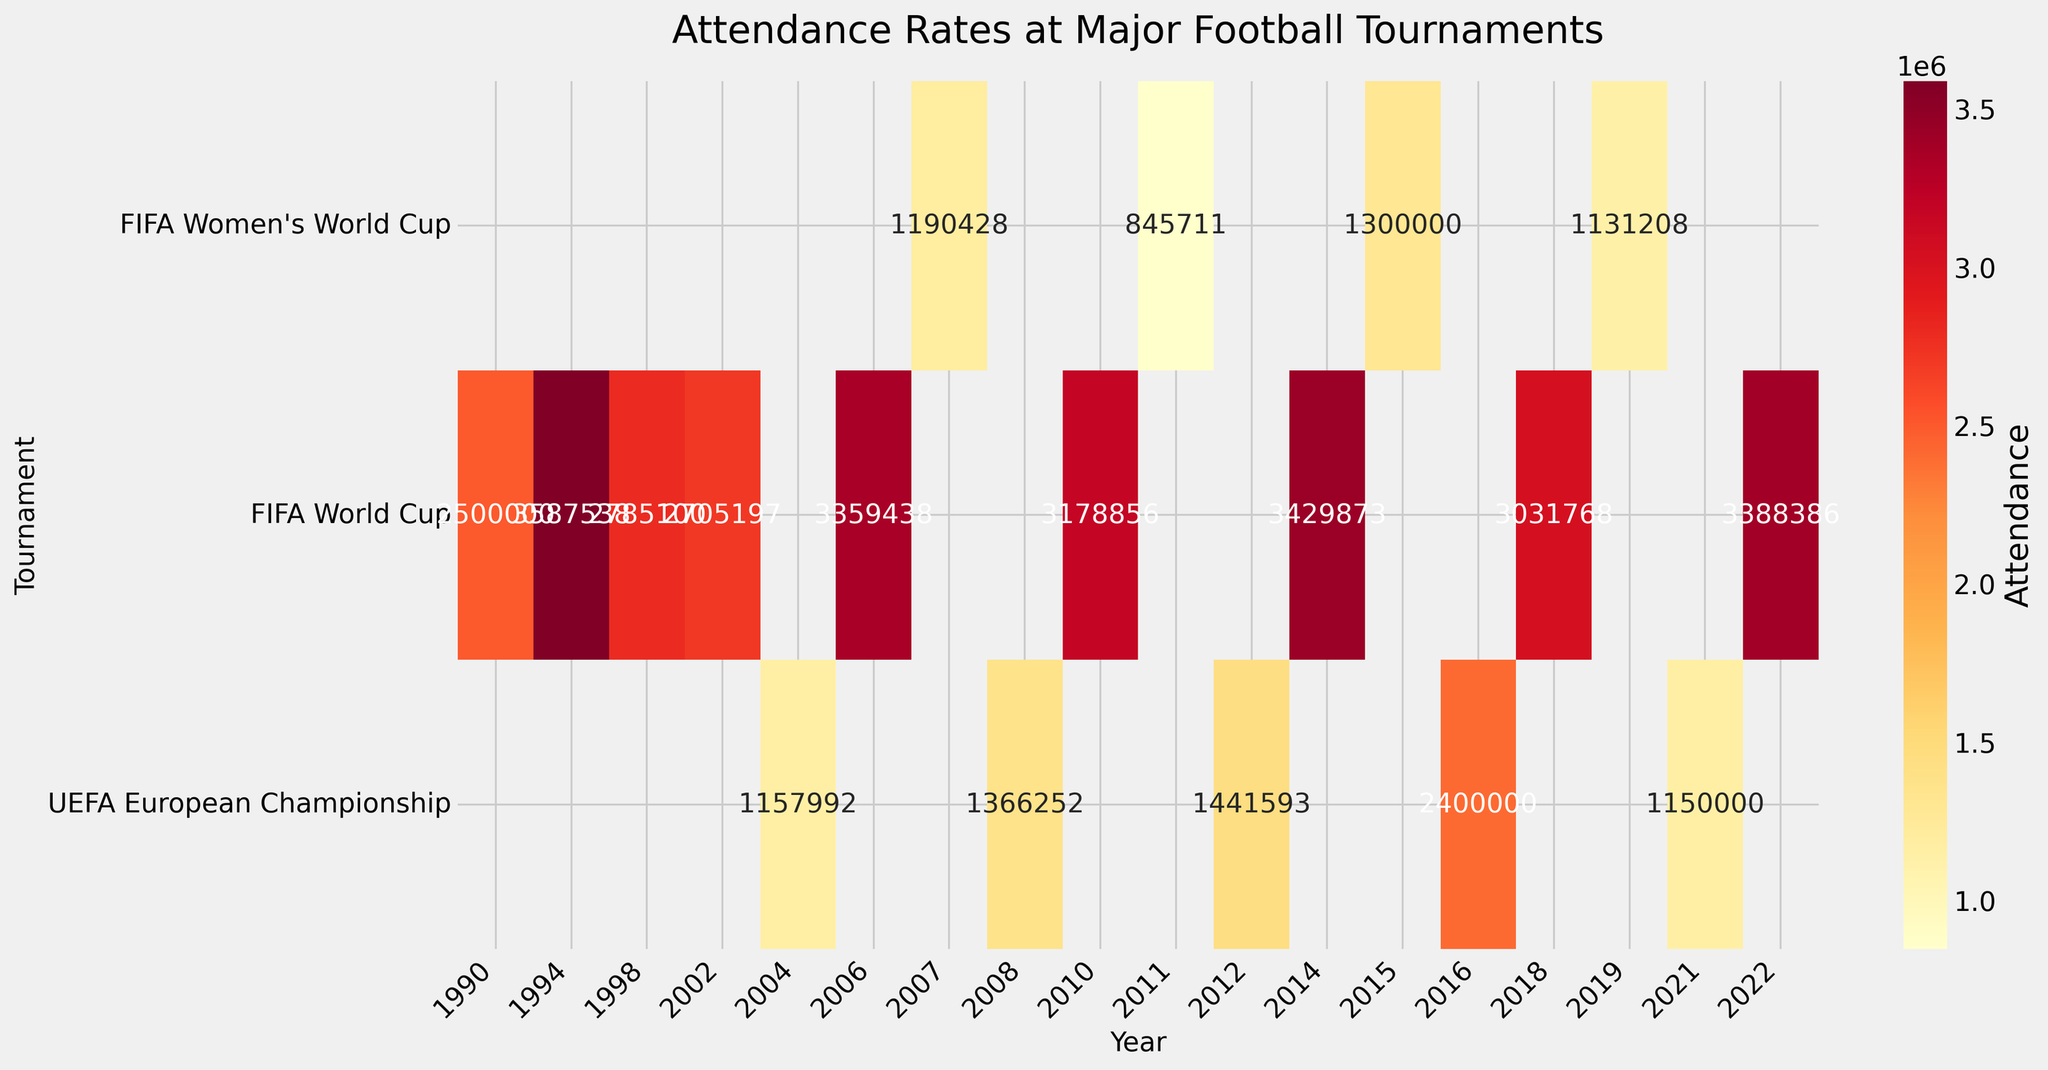What is the title of the figure? The title is usually displayed prominently at the top of the figure. In this case, the title is located above the heatmap.
Answer: Attendance Rates at Major Football Tournaments Which tournament had the highest attendance in 1994? Looking at the column for the year 1994, locate the cell with the highest value. The highest attendance in 1994 is under the FIFA World Cup.
Answer: FIFA World Cup What was the attendance at the UEFA European Championship in 2012? To find this information, look in the row for the UEFA European Championship and trace it to the column for the year 2012. The attendance value in this cell is the answer.
Answer: 1441593 Which years had the FIFA World Cup with attendance greater than 3 million? Examine the FIFA World Cup row for attendance values greater than 3 million and note the corresponding years. The years are 1994, 2006, 2010, 2014, 2018, and 2022.
Answer: 1994, 2006, 2010, 2014, 2018, 2022 What is the average attendance for the FIFA Women's World Cup from 2007 to 2019? Identify the attendance values for the FIFA Women's World Cup across 2007, 2011, 2015, and 2019, then calculate the average. The values are 1190428, 845711, 1300000, and 1131208 respectively. The average is (1190428 + 845711 + 1300000 + 1131208) / 4 = 1114336.75.
Answer: 1114336.75 How does the attendance in the 1998 FIFA World Cup compare to the 2002 FIFA World Cup? Compare the attendance values for the FIFA World Cup in 1998 and 2002. The values are 2785100 in 1998 and 2705197 in 2002. The 1998 FIFA World Cup had a higher attendance.
Answer: 1998 had higher attendance Which tournament has the lowest overall attendance among those shown? Examine all the attendance values for each tournament and identify the lowest value. The UEFA European Championship in 2021 has the lowest attendance of 1150000.
Answer: UEFA European Championship Did any major football tournaments have an attendance over 3 million in 2018? Check the attendance values in the column for the year 2018. For 2018, the FIFA World Cup had an attendance of 3031768, which is over 3 million.
Answer: Yes What was the total attendance for all tournaments in 2006? Sum the attendance values for all tournaments in the year 2006. The only tournament listed for 2006 is the FIFA World Cup with an attendance of 3359438.
Answer: 3359438 Which countries hosted the UEFA European Championship across the data provided? Identify all unique countries listed in the UEFA European Championship row. Countries are Portugal, Austria/Switzerland, Poland/Ukraine, France, Various.
Answer: Portugal, Austria/Switzerland, Poland/Ukraine, France, Various 